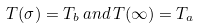Convert formula to latex. <formula><loc_0><loc_0><loc_500><loc_500>T ( \sigma ) = T _ { b } \, a n d \, T ( \infty ) = T _ { a }</formula> 